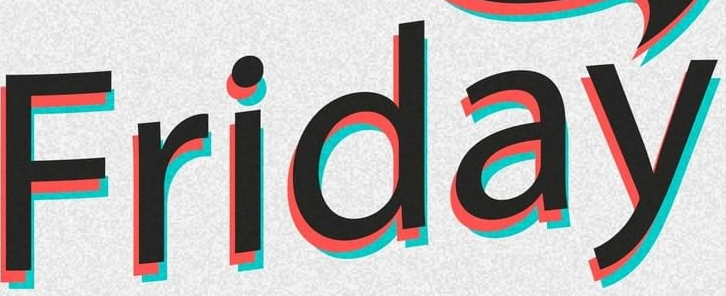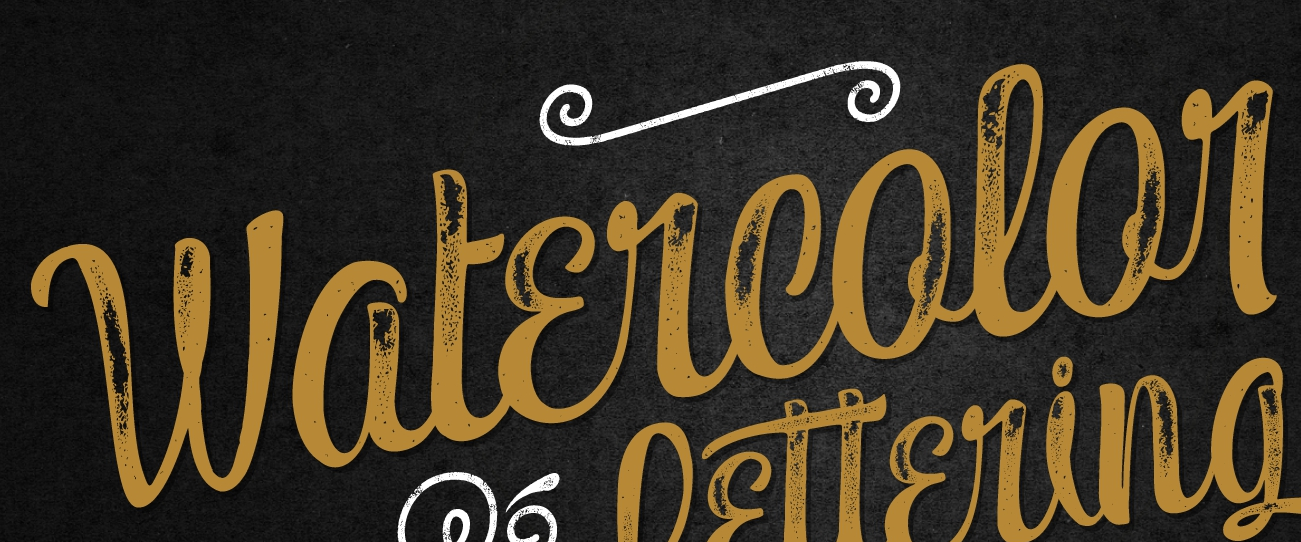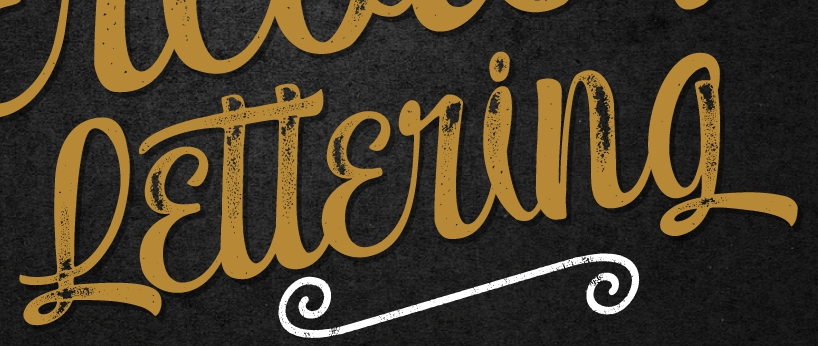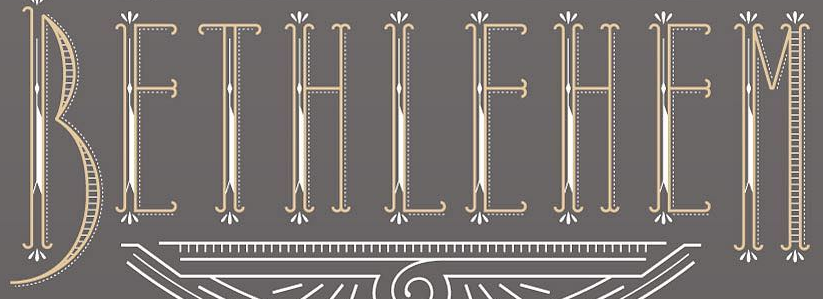What words are shown in these images in order, separated by a semicolon? Friday; Watɛrcolor; Lɛttɛring; BEIHIEHEM 